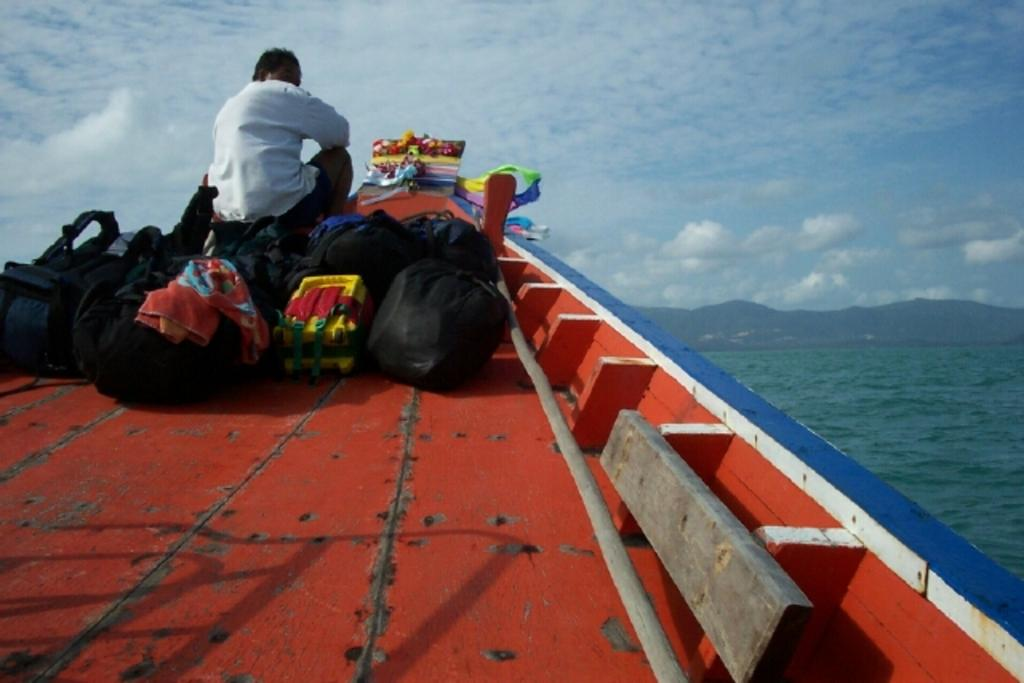What is the person in the image doing? There is a person sitting in the image. What can be seen on the boat with the person? There are luggage bags on the boat. Where is the boat located? The boat is on water. What is happening with the water in the image? Water is flowing in the image. What type of landscape can be seen in the background? There are hills visible in the image. What is visible in the sky? Clouds are present in the sky. What type of cake is being served on the boat in the image? There is no cake present in the image; it features a person sitting on a boat with luggage bags. 